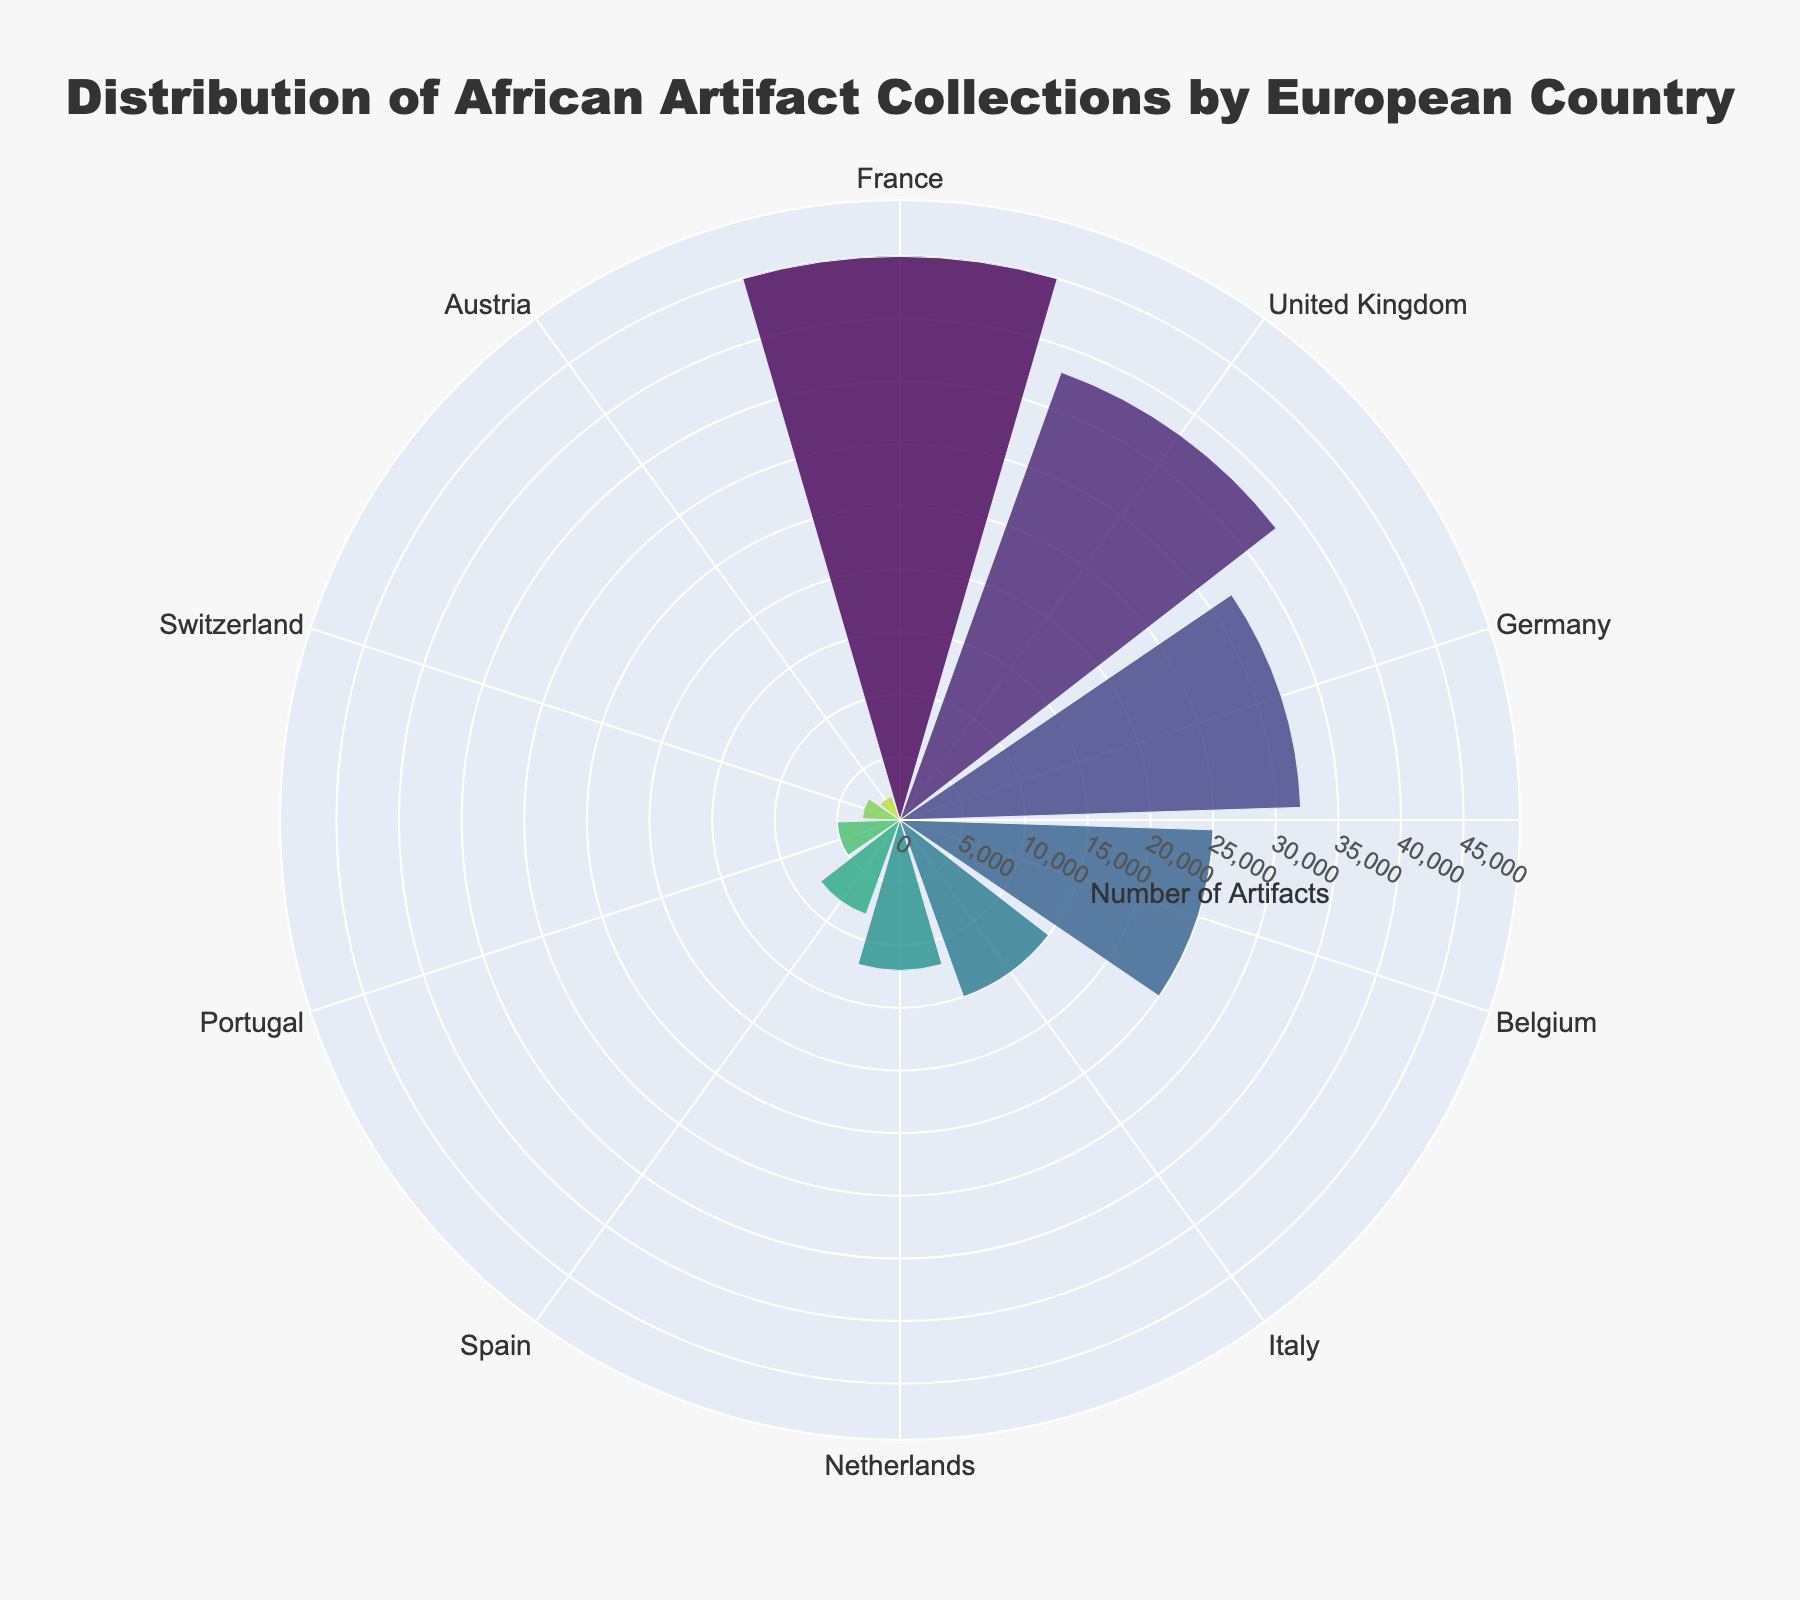What's the title of the plot? The title is displayed at the top center of the plot.
Answer: "Distribution of African Artifact Collections by European Country" Which country has the largest collection of African artifacts? The largest segment in the chart corresponds to the country with the highest value on the radial axis.
Answer: France How many African artifacts are collected by Belgium? Look at the length of the segment labeled "Belgium" and read the radial axis value.
Answer: 25,000 Compare the collections between the United Kingdom and Germany. Which country has more, and by how much? Check the length of the segments for both countries and subtract the collection count of the smaller from the larger.
Answer: The United Kingdom has 6,000 more artifacts What is the combined collection count for the United Kingdom and France? Add the collection counts for the United Kingdom (38,000) and France (45,000).
Answer: 83,000 Which country has the smallest collection of African artifacts? The smallest segment in the chart corresponds to the country with the lowest value on the radial axis.
Answer: Austria Estimate the average collection count for all countries. Sum all collection counts and divide by the number of countries (10). (45,000 + 38,000 + 32,000 + 25,000 + 15,000 + 12,000 + 8,000 + 5,000 + 3,000 + 2,000) / 10
Answer: 18,500 Are there any countries with similar quantities of African artifacts? Compare the segments visually. Countries with similar segment lengths have similar quantities.
Answer: France and the United Kingdom have similar counts What is the range of collection counts displayed in the chart? The range is the difference between the highest and lowest collection counts.
Answer: 45,000 - 2,000 = 43,000 How does Italy's collection compare to Spain's collection? Compare the segment lengths for Italy (15,000) and Spain (8,000).
Answer: Italy has 7,000 more artifacts 